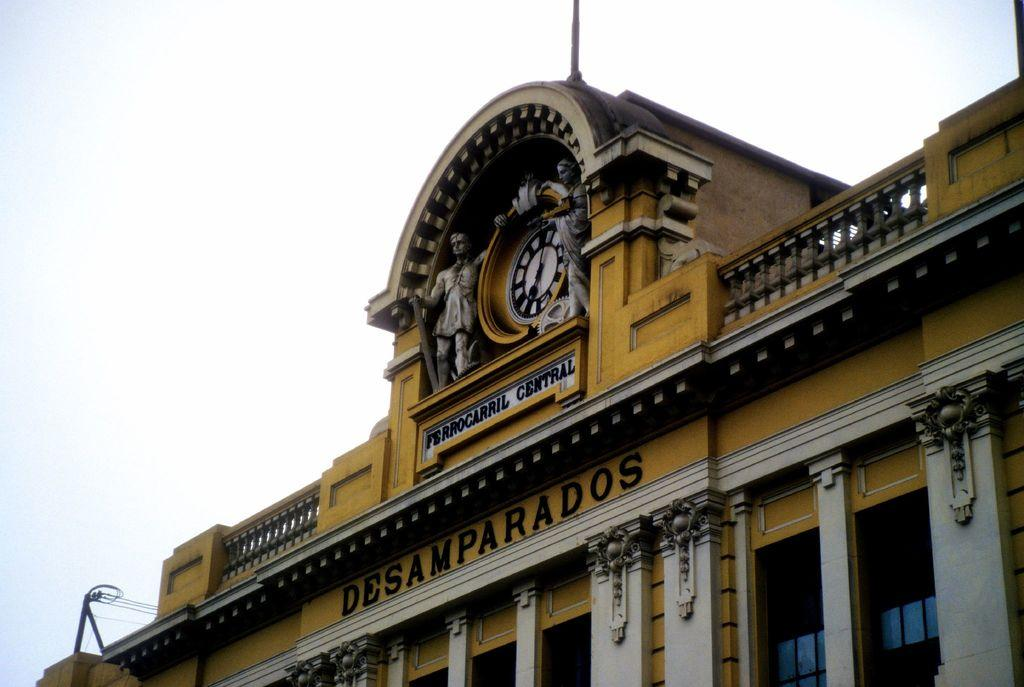<image>
Give a short and clear explanation of the subsequent image. A clock at the top of the Ferrocarril Central Desamparados building. 